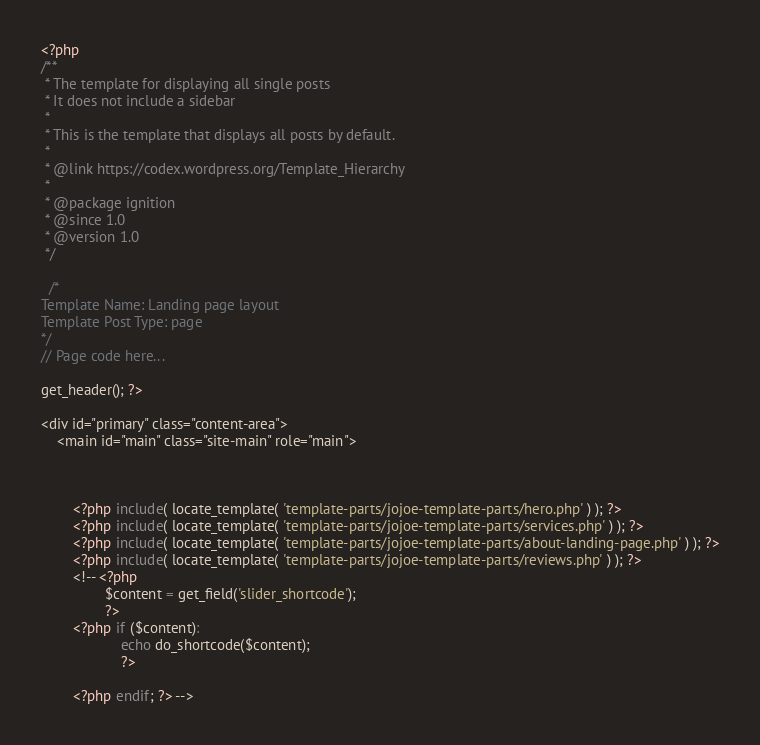<code> <loc_0><loc_0><loc_500><loc_500><_PHP_><?php
/**
 * The template for displaying all single posts
 * It does not include a sidebar
 *
 * This is the template that displays all posts by default.
 *
 * @link https://codex.wordpress.org/Template_Hierarchy
 *
 * @package ignition
 * @since 1.0
 * @version 1.0
 */

  /*
Template Name: Landing page layout
Template Post Type: page
*/
// Page code here...

get_header(); ?>

<div id="primary" class="content-area">
	<main id="main" class="site-main" role="main">



		<?php include( locate_template( 'template-parts/jojoe-template-parts/hero.php' ) ); ?>
		<?php include( locate_template( 'template-parts/jojoe-template-parts/services.php' ) ); ?>
		<?php include( locate_template( 'template-parts/jojoe-template-parts/about-landing-page.php' ) ); ?>
		<?php include( locate_template( 'template-parts/jojoe-template-parts/reviews.php' ) ); ?>
		<!-- <?php 
				$content = get_field('slider_shortcode');
				?>
		<?php if ($content):				
                    echo do_shortcode($content);
                    ?>

		<?php endif; ?> --></code> 